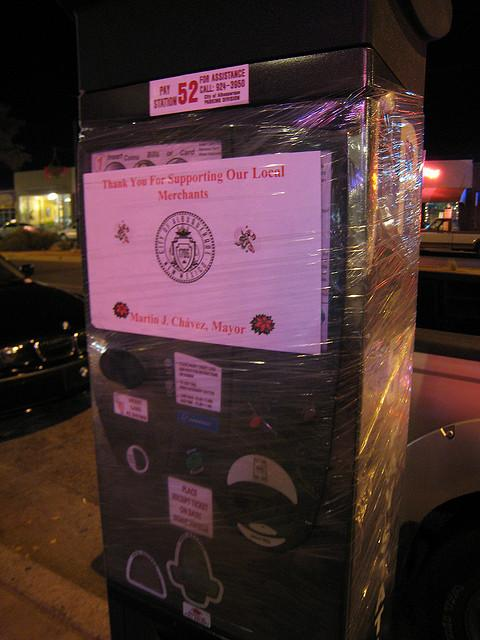This machine is meant to assist what type people in payments?

Choices:
A) bikers
B) motorists
C) unicyclists
D) prisoners motorists 